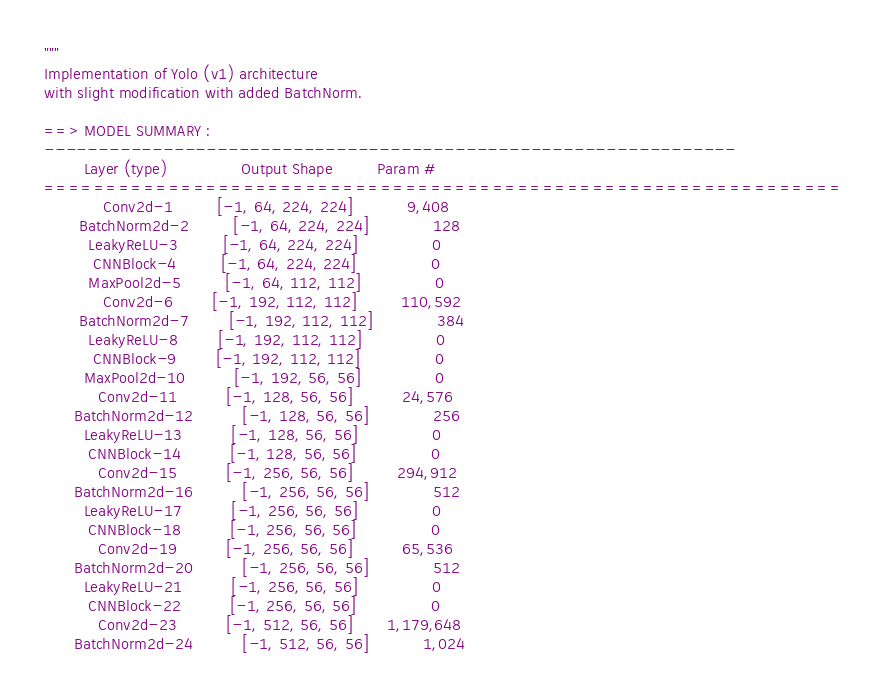<code> <loc_0><loc_0><loc_500><loc_500><_Python_>
"""
Implementation of Yolo (v1) architecture
with slight modification with added BatchNorm.

==> MODEL SUMMARY :
----------------------------------------------------------------
        Layer (type)               Output Shape         Param #
================================================================
            Conv2d-1         [-1, 64, 224, 224]           9,408
       BatchNorm2d-2         [-1, 64, 224, 224]             128
         LeakyReLU-3         [-1, 64, 224, 224]               0
          CNNBlock-4         [-1, 64, 224, 224]               0
         MaxPool2d-5         [-1, 64, 112, 112]               0
            Conv2d-6        [-1, 192, 112, 112]         110,592
       BatchNorm2d-7        [-1, 192, 112, 112]             384
         LeakyReLU-8        [-1, 192, 112, 112]               0
          CNNBlock-9        [-1, 192, 112, 112]               0
        MaxPool2d-10          [-1, 192, 56, 56]               0
           Conv2d-11          [-1, 128, 56, 56]          24,576
      BatchNorm2d-12          [-1, 128, 56, 56]             256
        LeakyReLU-13          [-1, 128, 56, 56]               0
         CNNBlock-14          [-1, 128, 56, 56]               0
           Conv2d-15          [-1, 256, 56, 56]         294,912
      BatchNorm2d-16          [-1, 256, 56, 56]             512
        LeakyReLU-17          [-1, 256, 56, 56]               0
         CNNBlock-18          [-1, 256, 56, 56]               0
           Conv2d-19          [-1, 256, 56, 56]          65,536
      BatchNorm2d-20          [-1, 256, 56, 56]             512
        LeakyReLU-21          [-1, 256, 56, 56]               0
         CNNBlock-22          [-1, 256, 56, 56]               0
           Conv2d-23          [-1, 512, 56, 56]       1,179,648
      BatchNorm2d-24          [-1, 512, 56, 56]           1,024</code> 